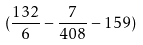<formula> <loc_0><loc_0><loc_500><loc_500>( \frac { 1 3 2 } { 6 } - \frac { 7 } { 4 0 8 } - 1 5 9 )</formula> 